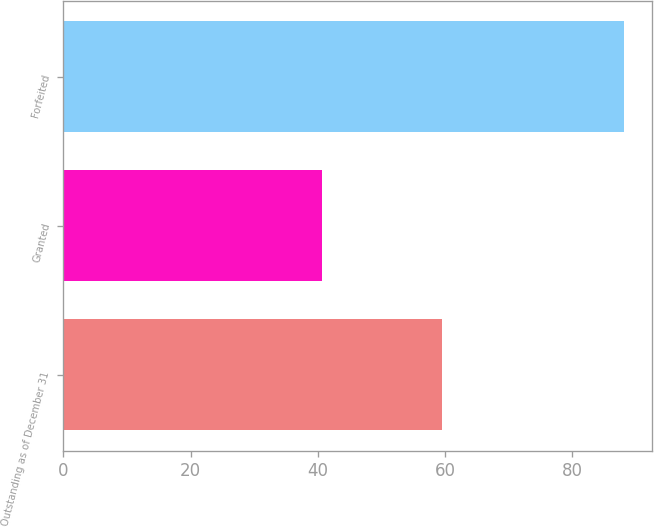Convert chart to OTSL. <chart><loc_0><loc_0><loc_500><loc_500><bar_chart><fcel>Outstanding as of December 31<fcel>Granted<fcel>Forfeited<nl><fcel>59.48<fcel>40.62<fcel>88.09<nl></chart> 